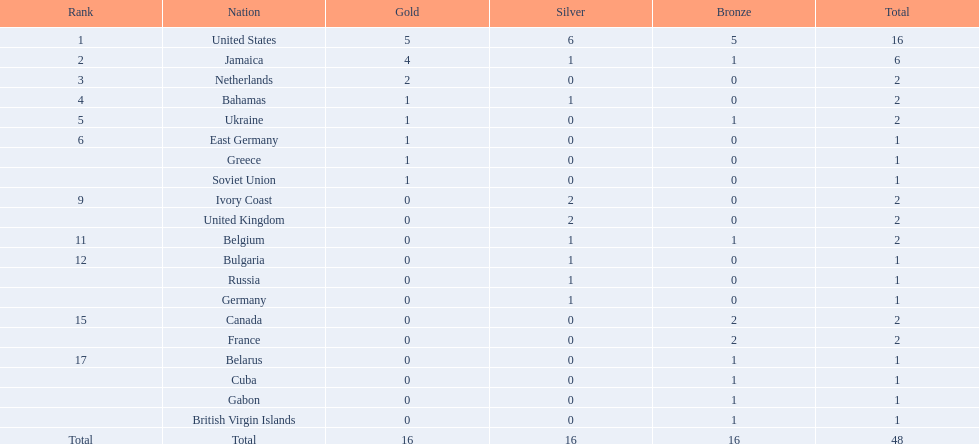What is the overall count of gold medals secured by jamaica? 4. 